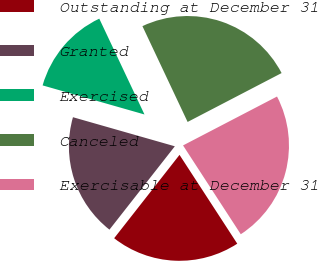<chart> <loc_0><loc_0><loc_500><loc_500><pie_chart><fcel>Outstanding at December 31<fcel>Granted<fcel>Exercised<fcel>Canceled<fcel>Exercisable at December 31<nl><fcel>19.76%<fcel>18.84%<fcel>13.56%<fcel>24.38%<fcel>23.46%<nl></chart> 